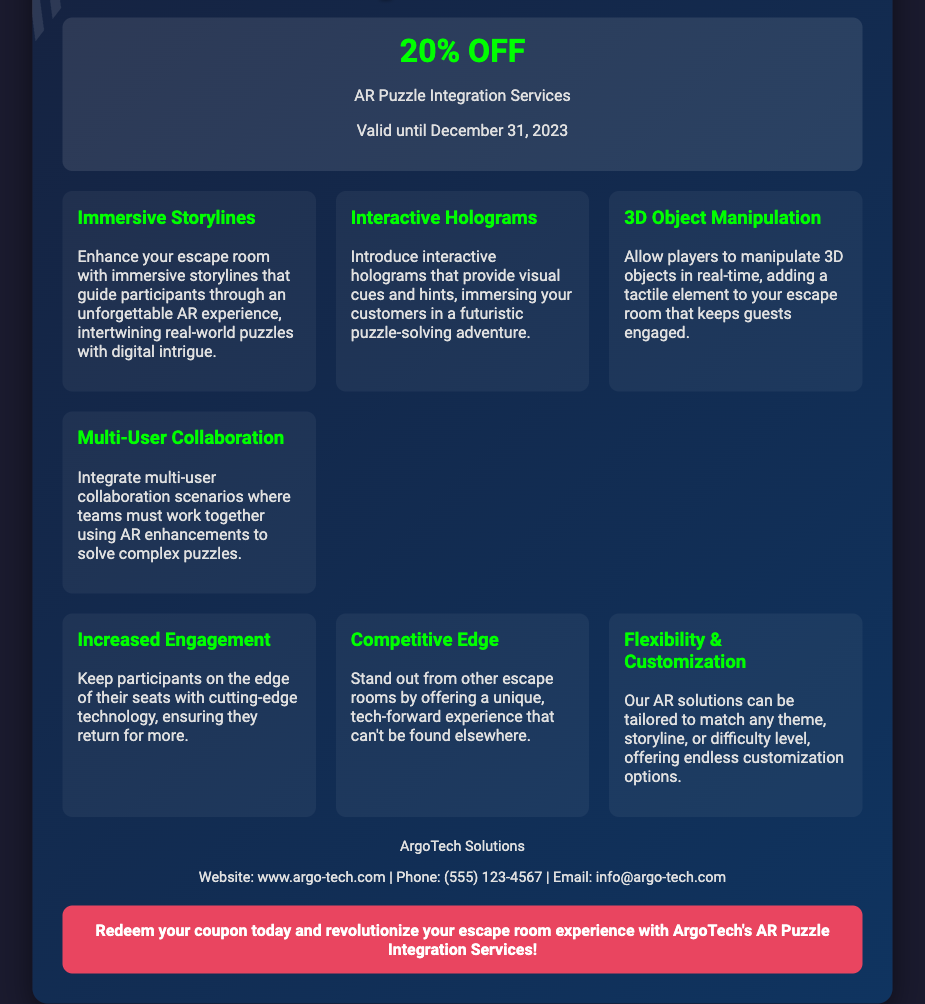What is the discount offered on AR Puzzle Integration Services? The document states that there is a 20% discount on AR Puzzle Integration Services.
Answer: 20% OFF What is the valid date for the coupon? The coupon is valid until December 31, 2023.
Answer: December 31, 2023 What is the name of the company offering the coupon? The company offering the coupon is ArgoTech Solutions.
Answer: ArgoTech Solutions Which feature allows players to manipulate 3D objects in real-time? The feature that allows this is titled "3D Object Manipulation."
Answer: 3D Object Manipulation What benefit ensures participants return for more? The benefit that ensures this is increased engagement.
Answer: Increased Engagement What type of scenarios can be integrated for teams in the escape room? The document mentions that multi-user collaboration scenarios can be integrated.
Answer: Multi-User Collaboration What color is used for the discount text in the coupon? The discount text is colored green.
Answer: green How can the AR solutions be customized? The document states that solutions can be tailored to match any theme, storyline, or difficulty level.
Answer: Any theme, storyline, or difficulty level 